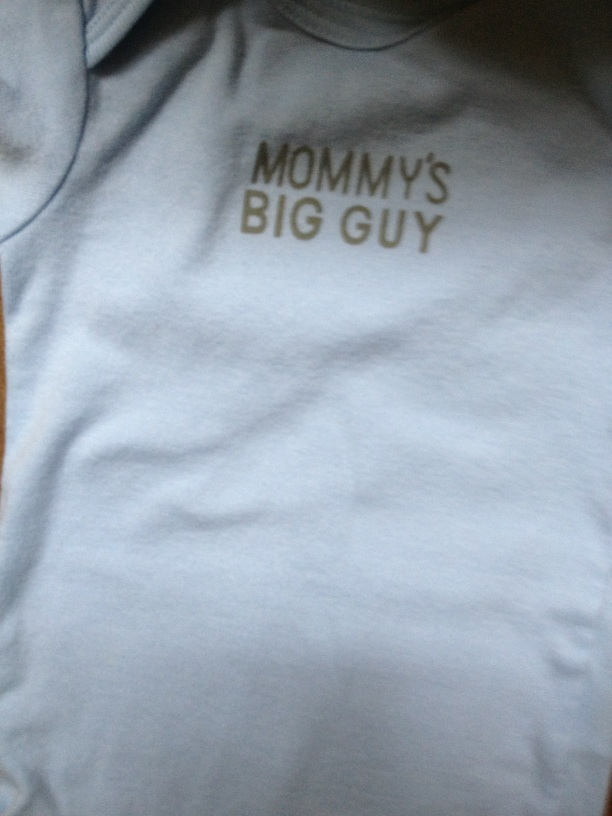How would you advertise this shirt if you were in charge of marketing? Join the heartwarming movement of proud parents everywhere! Our 'Mommy's Big Guy' shirt is the perfect way to celebrate your little one's special place in your heart. Made from soft, high-quality materials, this shirt ensures comfort and style for your baby. Available in various colors and sizes, it's time to make your baby the center of attention. Order now and capture those precious moments with 'Mommy's Big Guy'! 